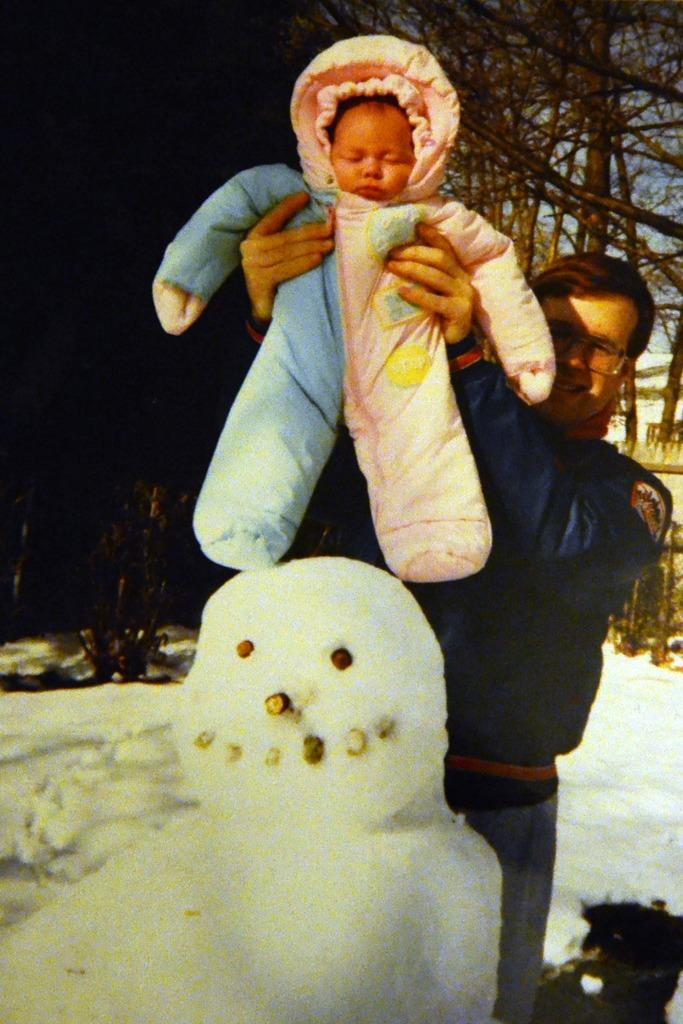Who is present in the image? There is a man in the image. What is the man doing in the image? The man is holding a small kid. What can be seen in the background of the image? Trees are present in the background of the image. What is the main feature in the foreground of the image? There is a snowman made of snow in the image. What type of books does the snowman have in its selection? There are no books present in the image, as the main feature in the foreground is a snowman made of snow. 